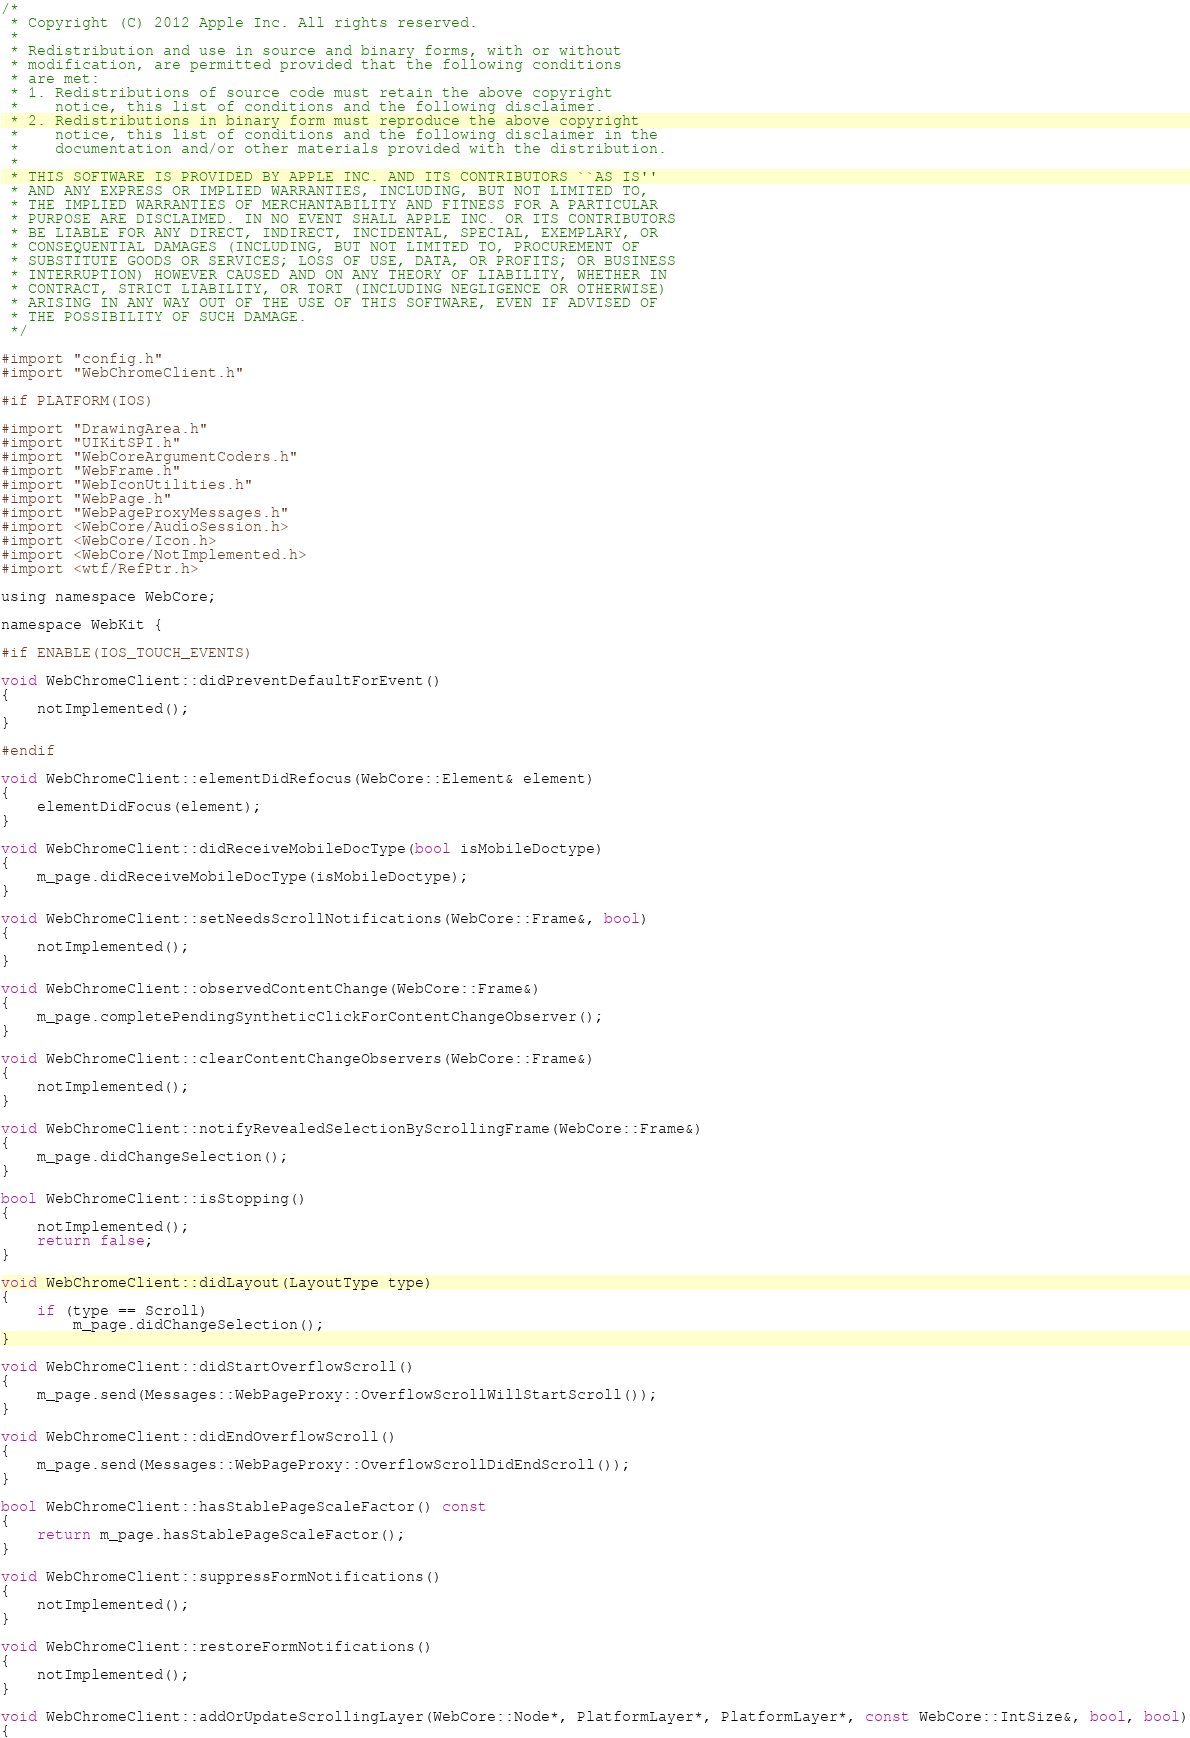<code> <loc_0><loc_0><loc_500><loc_500><_ObjectiveC_>/*
 * Copyright (C) 2012 Apple Inc. All rights reserved.
 *
 * Redistribution and use in source and binary forms, with or without
 * modification, are permitted provided that the following conditions
 * are met:
 * 1. Redistributions of source code must retain the above copyright
 *    notice, this list of conditions and the following disclaimer.
 * 2. Redistributions in binary form must reproduce the above copyright
 *    notice, this list of conditions and the following disclaimer in the
 *    documentation and/or other materials provided with the distribution.
 *
 * THIS SOFTWARE IS PROVIDED BY APPLE INC. AND ITS CONTRIBUTORS ``AS IS''
 * AND ANY EXPRESS OR IMPLIED WARRANTIES, INCLUDING, BUT NOT LIMITED TO,
 * THE IMPLIED WARRANTIES OF MERCHANTABILITY AND FITNESS FOR A PARTICULAR
 * PURPOSE ARE DISCLAIMED. IN NO EVENT SHALL APPLE INC. OR ITS CONTRIBUTORS
 * BE LIABLE FOR ANY DIRECT, INDIRECT, INCIDENTAL, SPECIAL, EXEMPLARY, OR
 * CONSEQUENTIAL DAMAGES (INCLUDING, BUT NOT LIMITED TO, PROCUREMENT OF
 * SUBSTITUTE GOODS OR SERVICES; LOSS OF USE, DATA, OR PROFITS; OR BUSINESS
 * INTERRUPTION) HOWEVER CAUSED AND ON ANY THEORY OF LIABILITY, WHETHER IN
 * CONTRACT, STRICT LIABILITY, OR TORT (INCLUDING NEGLIGENCE OR OTHERWISE)
 * ARISING IN ANY WAY OUT OF THE USE OF THIS SOFTWARE, EVEN IF ADVISED OF
 * THE POSSIBILITY OF SUCH DAMAGE.
 */

#import "config.h"
#import "WebChromeClient.h"

#if PLATFORM(IOS)

#import "DrawingArea.h"
#import "UIKitSPI.h"
#import "WebCoreArgumentCoders.h"
#import "WebFrame.h"
#import "WebIconUtilities.h"
#import "WebPage.h"
#import "WebPageProxyMessages.h"
#import <WebCore/AudioSession.h>
#import <WebCore/Icon.h>
#import <WebCore/NotImplemented.h>
#import <wtf/RefPtr.h>

using namespace WebCore;

namespace WebKit {

#if ENABLE(IOS_TOUCH_EVENTS)

void WebChromeClient::didPreventDefaultForEvent()
{
    notImplemented();
}

#endif

void WebChromeClient::elementDidRefocus(WebCore::Element& element)
{
    elementDidFocus(element);
}

void WebChromeClient::didReceiveMobileDocType(bool isMobileDoctype)
{
    m_page.didReceiveMobileDocType(isMobileDoctype);
}

void WebChromeClient::setNeedsScrollNotifications(WebCore::Frame&, bool)
{
    notImplemented();
}

void WebChromeClient::observedContentChange(WebCore::Frame&)
{
    m_page.completePendingSyntheticClickForContentChangeObserver();
}

void WebChromeClient::clearContentChangeObservers(WebCore::Frame&)
{
    notImplemented();
}

void WebChromeClient::notifyRevealedSelectionByScrollingFrame(WebCore::Frame&)
{
    m_page.didChangeSelection();
}

bool WebChromeClient::isStopping()
{
    notImplemented();
    return false;
}

void WebChromeClient::didLayout(LayoutType type)
{
    if (type == Scroll)
        m_page.didChangeSelection();
}

void WebChromeClient::didStartOverflowScroll()
{
    m_page.send(Messages::WebPageProxy::OverflowScrollWillStartScroll());
}

void WebChromeClient::didEndOverflowScroll()
{
    m_page.send(Messages::WebPageProxy::OverflowScrollDidEndScroll());
}

bool WebChromeClient::hasStablePageScaleFactor() const
{
    return m_page.hasStablePageScaleFactor();
}

void WebChromeClient::suppressFormNotifications()
{
    notImplemented();
}

void WebChromeClient::restoreFormNotifications()
{
    notImplemented();
}

void WebChromeClient::addOrUpdateScrollingLayer(WebCore::Node*, PlatformLayer*, PlatformLayer*, const WebCore::IntSize&, bool, bool)
{</code> 